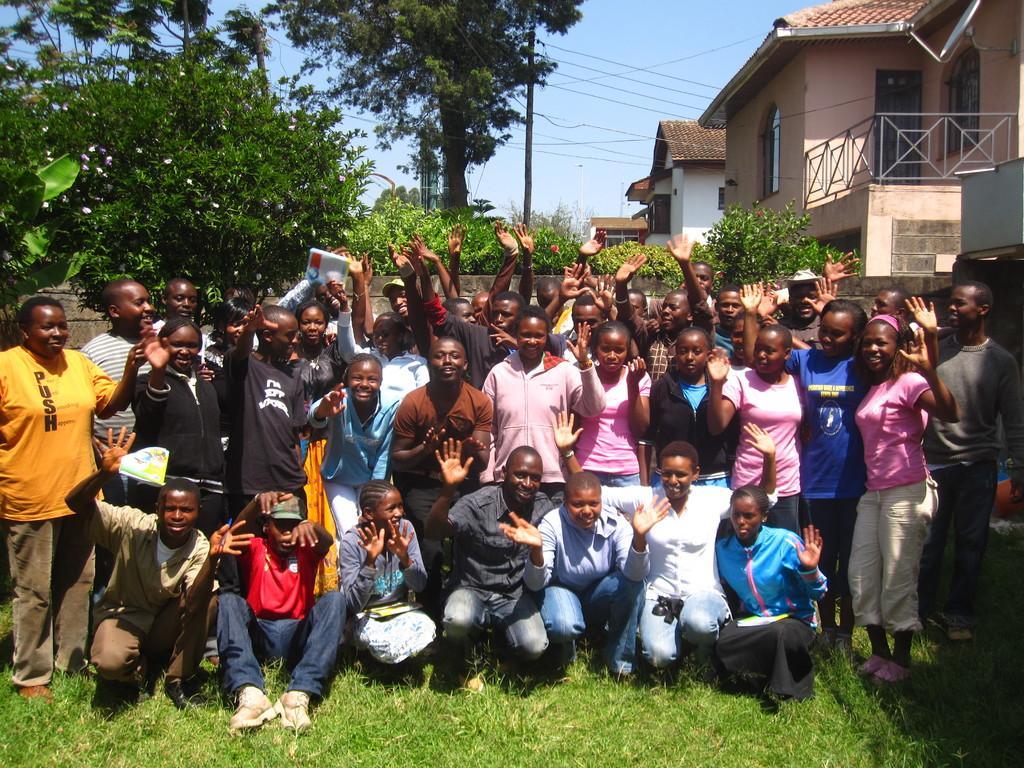How would you summarize this image in a sentence or two? A group of people are standing at here. On the right side there are houses and on the left side there are trees. 